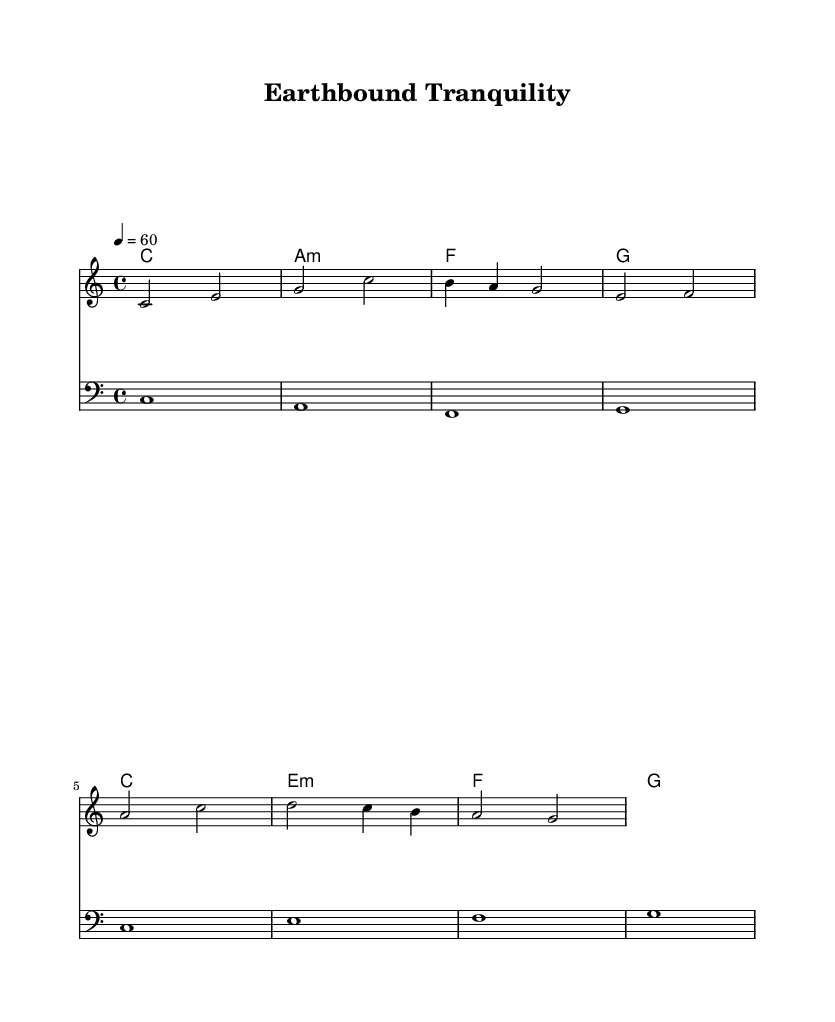What is the key signature of this music? The key signature is C major, which can be identified from the absence of any sharps or flats listed at the beginning of the staff.
Answer: C major What is the time signature of the piece? The time signature is 4/4, as indicated at the beginning of the score where it specifies the number of beats per measure and the note value that receives one beat.
Answer: 4/4 What is the tempo marking given in the score? The tempo marking is 60 beats per minute, which is denoted by the "tempo 4 = 60" instruction at the start. This indicates the speed of the piece.
Answer: 60 How many measures are in the melody section? The melody section has 4 measures, which can be counted by examining the melody line and noting the vertical bar lines that represent the end of each measure.
Answer: 4 What type of harmony is primarily used in this composition? The harmony consists of major and minor chords, as seen in the chord names reflected in the harmony section with C major, A minor, F major, and G major chords.
Answer: Major and minor chords How does the bassline relate to the melody? The bassline complements the melody by providing a foundation with root notes that align with the harmony underneath the melody, emphasizing the grounding theme of the composition.
Answer: Complementary foundation What is the primary mood or theme expressed in this piece? The primary mood expressed in this piece is tranquility, which is conveyed through the slow tempo, smooth melodic lines, and harmonic simplicity that evoke feelings of grounding and earthly connections.
Answer: Tranquility 